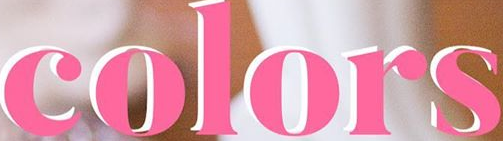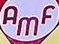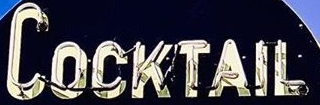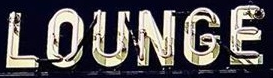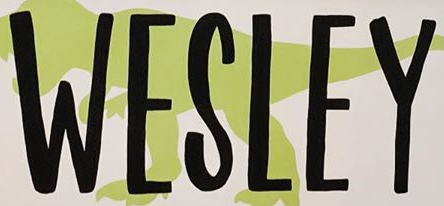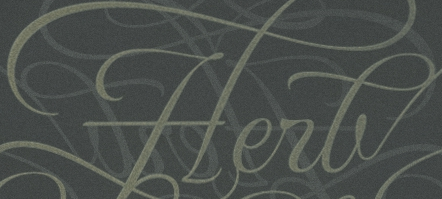What text is displayed in these images sequentially, separated by a semicolon? colors; AMF; COCKTAIL; LOUNGE; WESLEY; Herb 